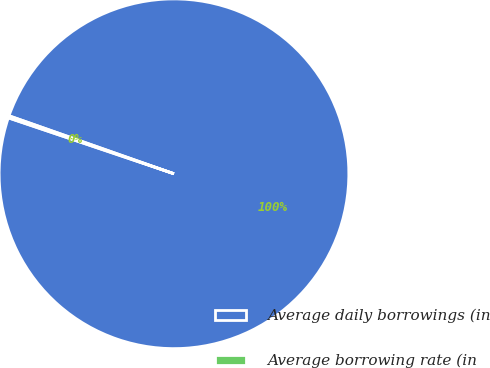Convert chart. <chart><loc_0><loc_0><loc_500><loc_500><pie_chart><fcel>Average daily borrowings (in<fcel>Average borrowing rate (in<nl><fcel>99.8%<fcel>0.2%<nl></chart> 